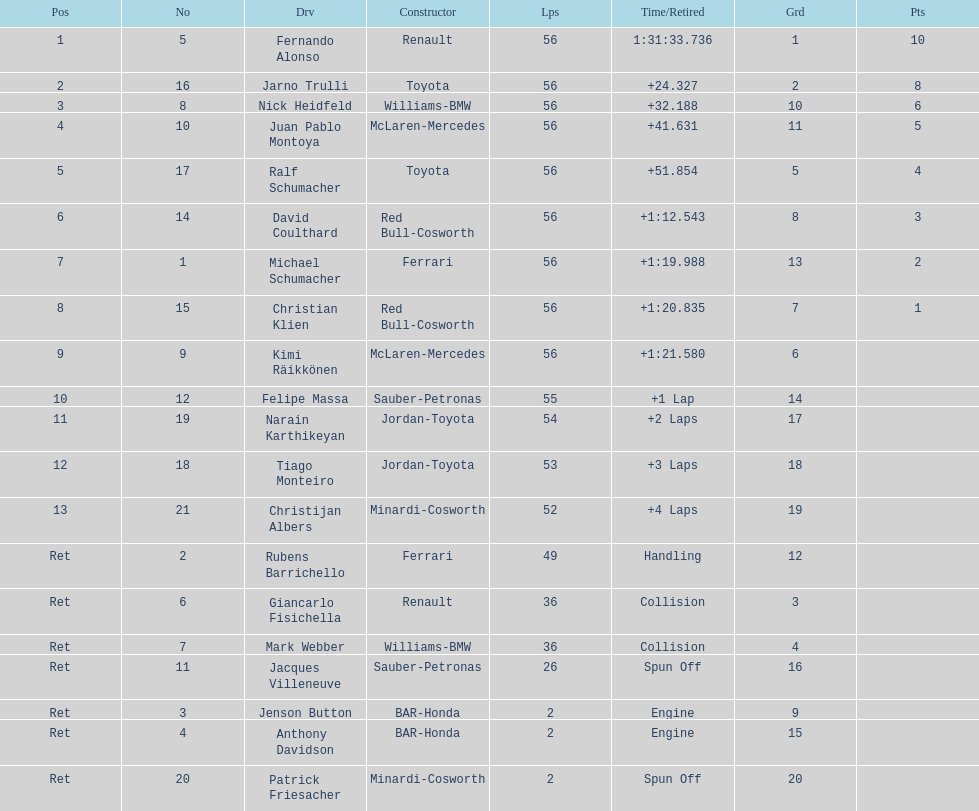Who was the last driver to actually finish the race? Christijan Albers. 